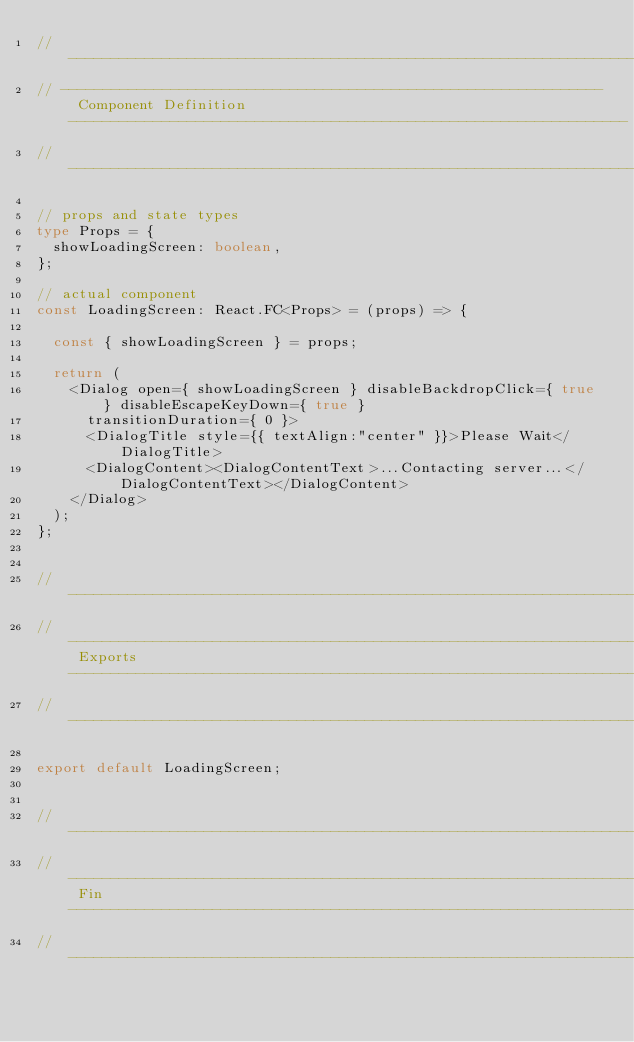Convert code to text. <code><loc_0><loc_0><loc_500><loc_500><_TypeScript_>// --------------------------------------------------------------------------------------------------------------------------------------------------------
// ---------------------------------------------------------------- Component Definition ------------------------------------------------------------------
// --------------------------------------------------------------------------------------------------------------------------------------------------------

// props and state types
type Props = {
  showLoadingScreen: boolean,
};

// actual component
const LoadingScreen: React.FC<Props> = (props) => {
  
  const { showLoadingScreen } = props;

  return (
    <Dialog open={ showLoadingScreen } disableBackdropClick={ true } disableEscapeKeyDown={ true }
      transitionDuration={ 0 }>
      <DialogTitle style={{ textAlign:"center" }}>Please Wait</DialogTitle>
      <DialogContent><DialogContentText>...Contacting server...</DialogContentText></DialogContent>
    </Dialog>
  );
};


// --------------------------------------------------------------------------------------------------------------------------------------------------------
// ----------------------------------------------------------------------- Exports ------------------------------------------------------------------------
// --------------------------------------------------------------------------------------------------------------------------------------------------------

export default LoadingScreen;


// --------------------------------------------------------------------------------------------------------------------------------------------------------
// ------------------------------------------------------------------------- Fin --------------------------------------------------------------------------
// --------------------------------------------------------------------------------------------------------------------------------------------------------</code> 